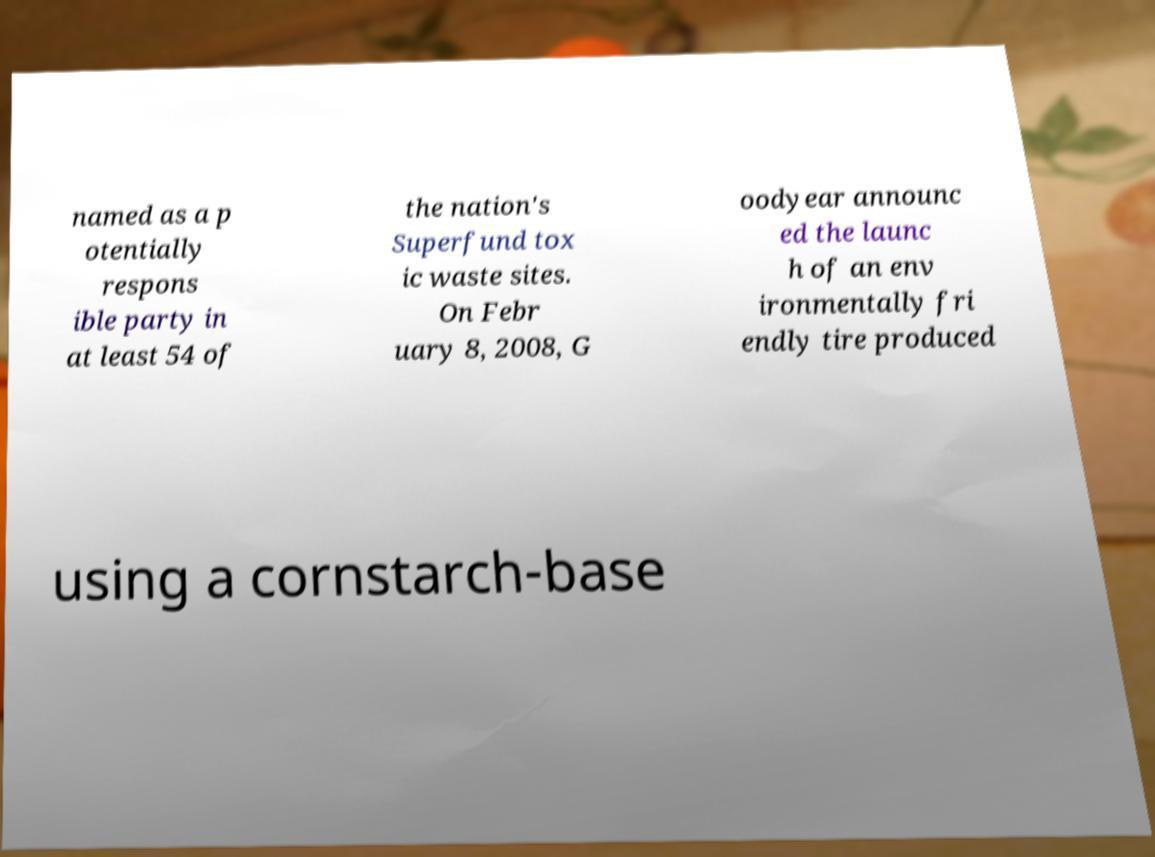For documentation purposes, I need the text within this image transcribed. Could you provide that? named as a p otentially respons ible party in at least 54 of the nation's Superfund tox ic waste sites. On Febr uary 8, 2008, G oodyear announc ed the launc h of an env ironmentally fri endly tire produced using a cornstarch-base 